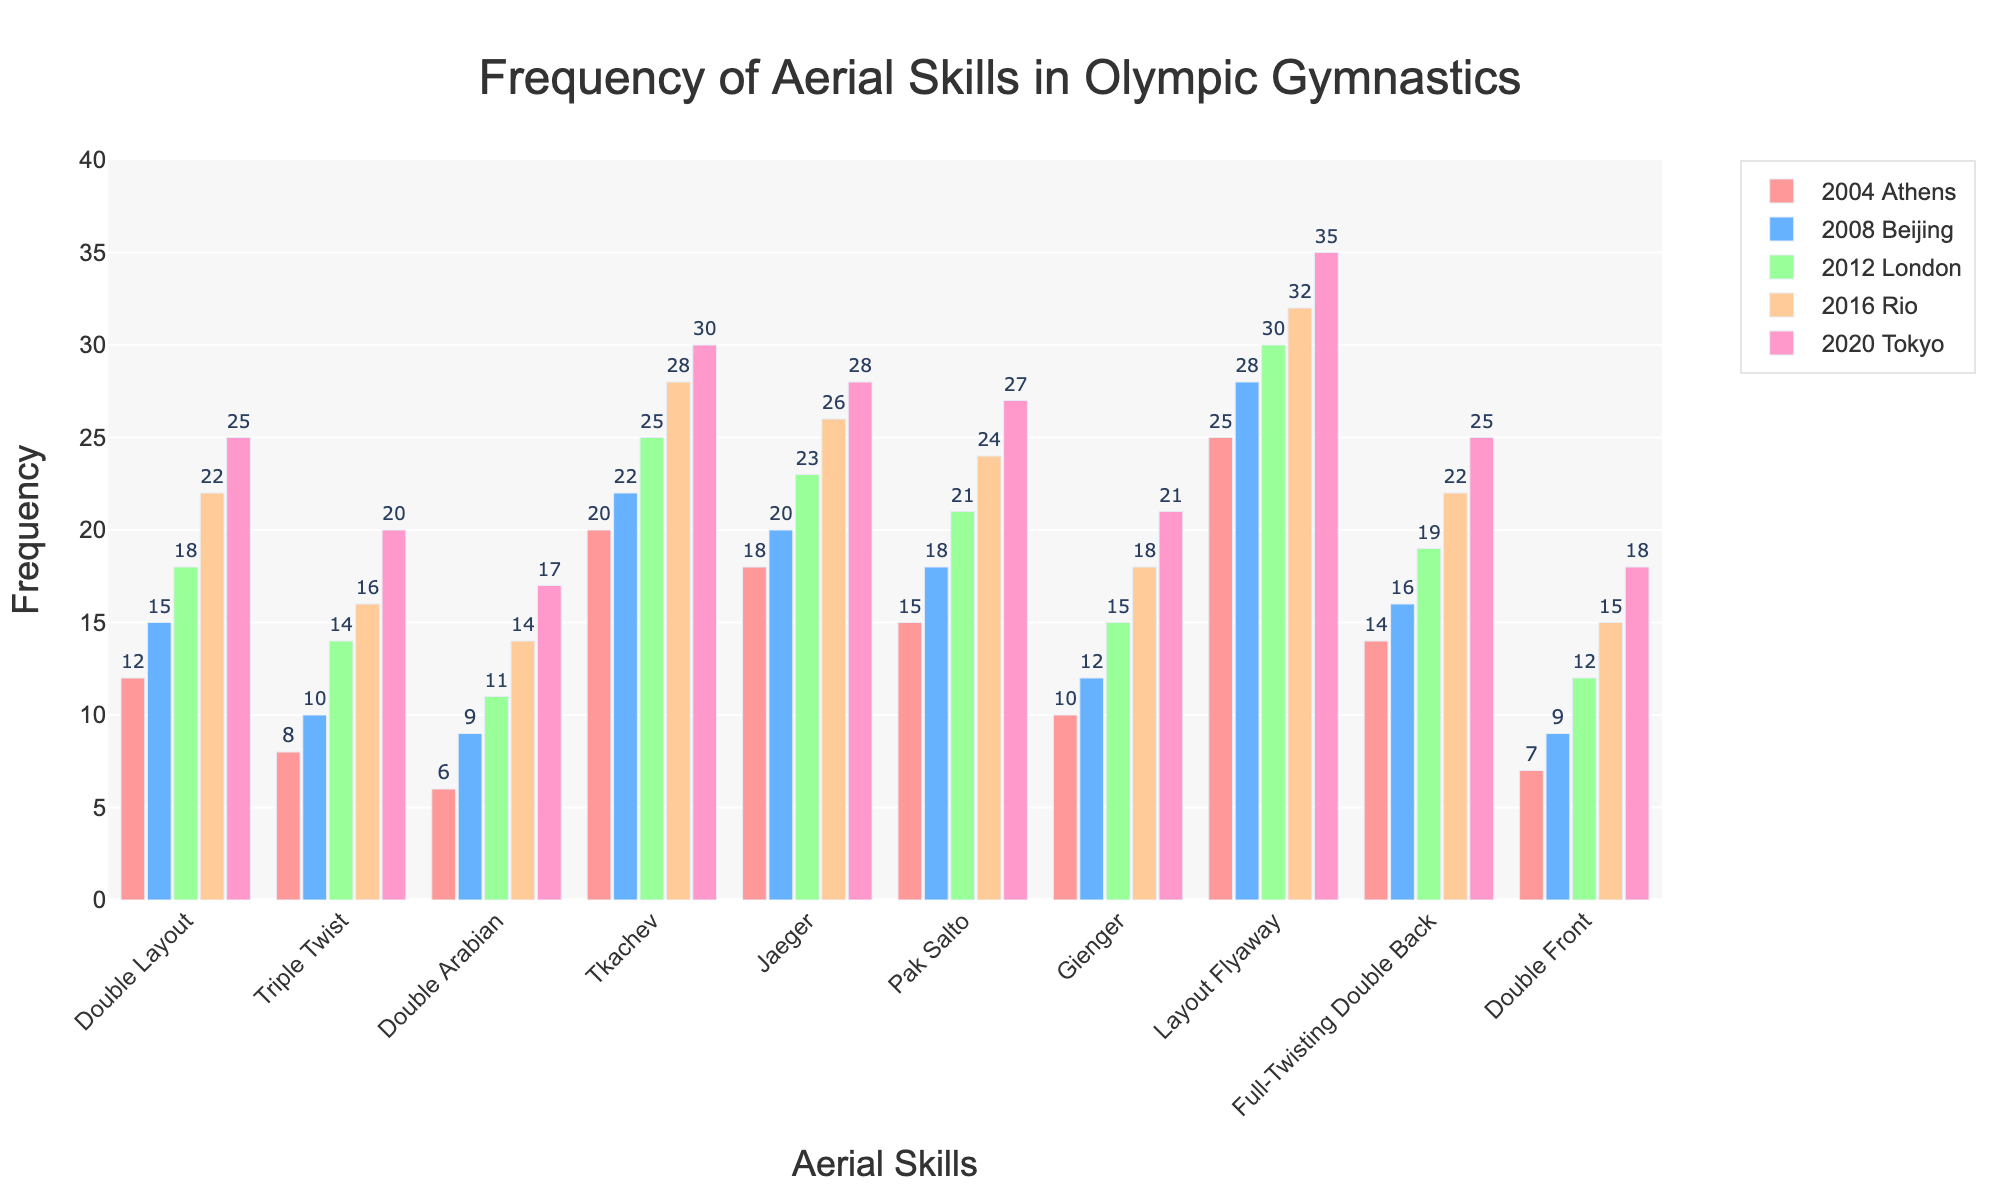Which aerial skill had the highest frequency in the 2004 Athens Olympics? In the figure, look at the bar heights for each skill in the 2004 Athens grouping. The tallest bar represents the highest frequency.
Answer: Layout Flyaway How did the frequency of the Double Layout change from the 2008 Beijing Olympics to the 2020 Tokyo Olympics? Observe the bars corresponding to the Double Layout skill in the groupings for the 2008 and 2020 Olympics. Subtract the 2008 value from the 2020 value to find the change in frequency.
Answer: Increase by 10 Which skill exhibited the smallest increase in frequency from 2004 to 2020? For each aerial skill, calculate the difference in bar heights from 2004 to 2020. Identify the skill with the smallest difference.
Answer: Double Front What is the total frequency of the Triple Twist across all five Olympics? Add the bar heights of the Triple Twist skill across all five Olympic groupings.
Answer: 68 Between which two consecutive Olympics did the Tkachev skill show the highest increase in frequency? Calculate the frequency differences of the Tkachev skill between each consecutive Olympics (2004-2008, 2008-2012, 2012-2016, 2016-2020) and identify the maximum difference.
Answer: 2008 to 2012 Which aerial skill consistently had an increasing trend over all five Olympics? For each skill, observe the bar heights across all five Olympics and identify the one(s) that continuously increase each year.
Answer: All skills Compare the frequency of the Pak Salto in the 2016 Rio Olympics with the Double Arabian in the same year. Which was higher and by how much? Compare the bar heights for Pak Salto and Double Arabian in the 2016 grouping and subtract the smaller value from the larger one.
Answer: Pak Salto by 10 What is the average frequency of the Jaeger skill over the past five Olympics? Add the Jaeger skill frequencies over the five Olympics and divide by the number of years (5).
Answer: 23 By how much did the frequency of the Full-Twisting Double Back increase from 2004 Athens to 2016 Rio? Subtract the 2004 bar height of the Full-Twisting Double Back from its 2016 bar height to find the increase.
Answer: 8 Which skill had a higher frequency in the 2020 Tokyo Olympics, the Double Layout or the Layout Flyaway, and by what margin? Compare the bar heights for Double Layout and Layout Flyaway in the 2020 grouping, then subtract the smaller value from the larger one.
Answer: Layout Flyaway by 10 